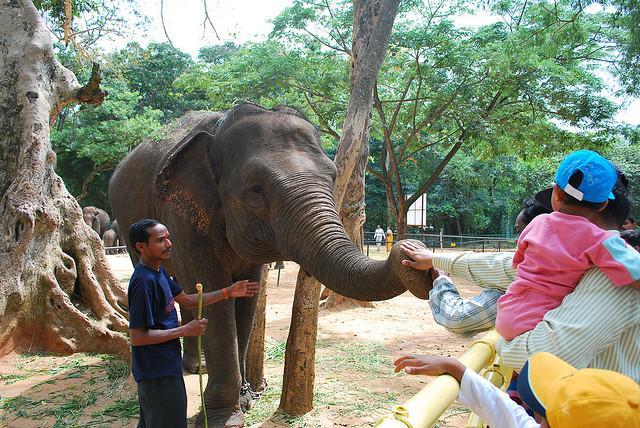What Disney cartoon character is based on this animal?

Choices:
A) barbie
B) dumbo
C) genie
D) aladdin dumbo 